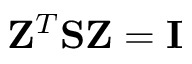<formula> <loc_0><loc_0><loc_500><loc_500>{ Z } ^ { T } { S } { Z } = { I }</formula> 